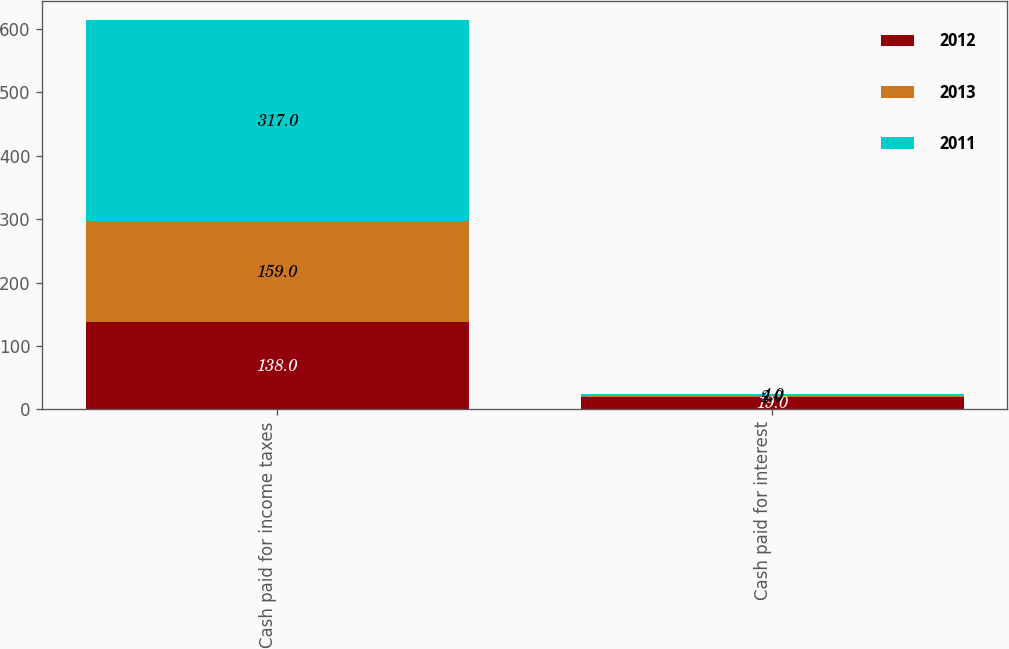Convert chart to OTSL. <chart><loc_0><loc_0><loc_500><loc_500><stacked_bar_chart><ecel><fcel>Cash paid for income taxes<fcel>Cash paid for interest<nl><fcel>2012<fcel>138<fcel>19<nl><fcel>2013<fcel>159<fcel>2<nl><fcel>2011<fcel>317<fcel>4<nl></chart> 